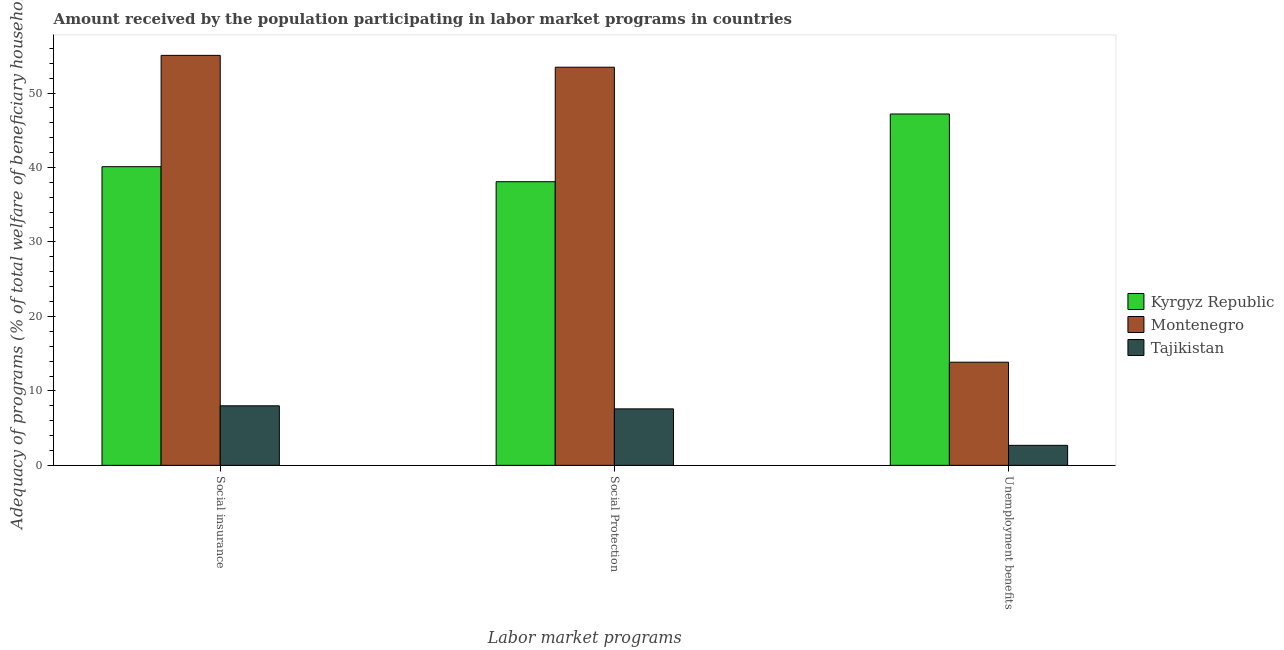Are the number of bars on each tick of the X-axis equal?
Ensure brevity in your answer.  Yes. How many bars are there on the 2nd tick from the right?
Offer a terse response. 3. What is the label of the 2nd group of bars from the left?
Offer a very short reply. Social Protection. What is the amount received by the population participating in unemployment benefits programs in Montenegro?
Your answer should be compact. 13.85. Across all countries, what is the maximum amount received by the population participating in social protection programs?
Your answer should be compact. 53.48. Across all countries, what is the minimum amount received by the population participating in social insurance programs?
Your response must be concise. 8. In which country was the amount received by the population participating in social insurance programs maximum?
Provide a short and direct response. Montenegro. In which country was the amount received by the population participating in unemployment benefits programs minimum?
Give a very brief answer. Tajikistan. What is the total amount received by the population participating in unemployment benefits programs in the graph?
Your answer should be compact. 63.73. What is the difference between the amount received by the population participating in unemployment benefits programs in Tajikistan and that in Montenegro?
Your answer should be very brief. -11.17. What is the difference between the amount received by the population participating in unemployment benefits programs in Montenegro and the amount received by the population participating in social insurance programs in Kyrgyz Republic?
Keep it short and to the point. -26.26. What is the average amount received by the population participating in social insurance programs per country?
Provide a succinct answer. 34.39. What is the difference between the amount received by the population participating in social insurance programs and amount received by the population participating in unemployment benefits programs in Tajikistan?
Ensure brevity in your answer.  5.31. In how many countries, is the amount received by the population participating in social insurance programs greater than 28 %?
Give a very brief answer. 2. What is the ratio of the amount received by the population participating in unemployment benefits programs in Montenegro to that in Kyrgyz Republic?
Offer a very short reply. 0.29. Is the difference between the amount received by the population participating in social insurance programs in Tajikistan and Montenegro greater than the difference between the amount received by the population participating in unemployment benefits programs in Tajikistan and Montenegro?
Offer a terse response. No. What is the difference between the highest and the second highest amount received by the population participating in unemployment benefits programs?
Give a very brief answer. 33.34. What is the difference between the highest and the lowest amount received by the population participating in social insurance programs?
Make the answer very short. 47.07. Is the sum of the amount received by the population participating in social protection programs in Kyrgyz Republic and Montenegro greater than the maximum amount received by the population participating in social insurance programs across all countries?
Provide a succinct answer. Yes. What does the 1st bar from the left in Unemployment benefits represents?
Provide a succinct answer. Kyrgyz Republic. What does the 1st bar from the right in Social insurance represents?
Ensure brevity in your answer.  Tajikistan. What is the difference between two consecutive major ticks on the Y-axis?
Offer a terse response. 10. Does the graph contain any zero values?
Ensure brevity in your answer.  No. Does the graph contain grids?
Your answer should be very brief. No. How many legend labels are there?
Your answer should be compact. 3. What is the title of the graph?
Your answer should be compact. Amount received by the population participating in labor market programs in countries. What is the label or title of the X-axis?
Provide a short and direct response. Labor market programs. What is the label or title of the Y-axis?
Your answer should be compact. Adequacy of programs (% of total welfare of beneficiary households). What is the Adequacy of programs (% of total welfare of beneficiary households) in Kyrgyz Republic in Social insurance?
Offer a very short reply. 40.12. What is the Adequacy of programs (% of total welfare of beneficiary households) of Montenegro in Social insurance?
Give a very brief answer. 55.07. What is the Adequacy of programs (% of total welfare of beneficiary households) in Tajikistan in Social insurance?
Keep it short and to the point. 8. What is the Adequacy of programs (% of total welfare of beneficiary households) of Kyrgyz Republic in Social Protection?
Offer a terse response. 38.1. What is the Adequacy of programs (% of total welfare of beneficiary households) in Montenegro in Social Protection?
Make the answer very short. 53.48. What is the Adequacy of programs (% of total welfare of beneficiary households) of Tajikistan in Social Protection?
Keep it short and to the point. 7.59. What is the Adequacy of programs (% of total welfare of beneficiary households) in Kyrgyz Republic in Unemployment benefits?
Your answer should be very brief. 47.19. What is the Adequacy of programs (% of total welfare of beneficiary households) of Montenegro in Unemployment benefits?
Provide a short and direct response. 13.85. What is the Adequacy of programs (% of total welfare of beneficiary households) in Tajikistan in Unemployment benefits?
Your answer should be compact. 2.69. Across all Labor market programs, what is the maximum Adequacy of programs (% of total welfare of beneficiary households) of Kyrgyz Republic?
Provide a succinct answer. 47.19. Across all Labor market programs, what is the maximum Adequacy of programs (% of total welfare of beneficiary households) of Montenegro?
Provide a short and direct response. 55.07. Across all Labor market programs, what is the maximum Adequacy of programs (% of total welfare of beneficiary households) in Tajikistan?
Keep it short and to the point. 8. Across all Labor market programs, what is the minimum Adequacy of programs (% of total welfare of beneficiary households) in Kyrgyz Republic?
Give a very brief answer. 38.1. Across all Labor market programs, what is the minimum Adequacy of programs (% of total welfare of beneficiary households) in Montenegro?
Offer a very short reply. 13.85. Across all Labor market programs, what is the minimum Adequacy of programs (% of total welfare of beneficiary households) in Tajikistan?
Make the answer very short. 2.69. What is the total Adequacy of programs (% of total welfare of beneficiary households) of Kyrgyz Republic in the graph?
Give a very brief answer. 125.41. What is the total Adequacy of programs (% of total welfare of beneficiary households) in Montenegro in the graph?
Your answer should be compact. 122.4. What is the total Adequacy of programs (% of total welfare of beneficiary households) of Tajikistan in the graph?
Provide a succinct answer. 18.27. What is the difference between the Adequacy of programs (% of total welfare of beneficiary households) in Kyrgyz Republic in Social insurance and that in Social Protection?
Make the answer very short. 2.02. What is the difference between the Adequacy of programs (% of total welfare of beneficiary households) in Montenegro in Social insurance and that in Social Protection?
Ensure brevity in your answer.  1.59. What is the difference between the Adequacy of programs (% of total welfare of beneficiary households) of Tajikistan in Social insurance and that in Social Protection?
Make the answer very short. 0.41. What is the difference between the Adequacy of programs (% of total welfare of beneficiary households) in Kyrgyz Republic in Social insurance and that in Unemployment benefits?
Your answer should be compact. -7.08. What is the difference between the Adequacy of programs (% of total welfare of beneficiary households) of Montenegro in Social insurance and that in Unemployment benefits?
Provide a succinct answer. 41.21. What is the difference between the Adequacy of programs (% of total welfare of beneficiary households) of Tajikistan in Social insurance and that in Unemployment benefits?
Give a very brief answer. 5.31. What is the difference between the Adequacy of programs (% of total welfare of beneficiary households) in Kyrgyz Republic in Social Protection and that in Unemployment benefits?
Ensure brevity in your answer.  -9.09. What is the difference between the Adequacy of programs (% of total welfare of beneficiary households) of Montenegro in Social Protection and that in Unemployment benefits?
Your answer should be very brief. 39.62. What is the difference between the Adequacy of programs (% of total welfare of beneficiary households) of Tajikistan in Social Protection and that in Unemployment benefits?
Keep it short and to the point. 4.9. What is the difference between the Adequacy of programs (% of total welfare of beneficiary households) in Kyrgyz Republic in Social insurance and the Adequacy of programs (% of total welfare of beneficiary households) in Montenegro in Social Protection?
Offer a terse response. -13.36. What is the difference between the Adequacy of programs (% of total welfare of beneficiary households) in Kyrgyz Republic in Social insurance and the Adequacy of programs (% of total welfare of beneficiary households) in Tajikistan in Social Protection?
Offer a very short reply. 32.53. What is the difference between the Adequacy of programs (% of total welfare of beneficiary households) in Montenegro in Social insurance and the Adequacy of programs (% of total welfare of beneficiary households) in Tajikistan in Social Protection?
Your answer should be compact. 47.48. What is the difference between the Adequacy of programs (% of total welfare of beneficiary households) of Kyrgyz Republic in Social insurance and the Adequacy of programs (% of total welfare of beneficiary households) of Montenegro in Unemployment benefits?
Make the answer very short. 26.26. What is the difference between the Adequacy of programs (% of total welfare of beneficiary households) in Kyrgyz Republic in Social insurance and the Adequacy of programs (% of total welfare of beneficiary households) in Tajikistan in Unemployment benefits?
Your answer should be very brief. 37.43. What is the difference between the Adequacy of programs (% of total welfare of beneficiary households) in Montenegro in Social insurance and the Adequacy of programs (% of total welfare of beneficiary households) in Tajikistan in Unemployment benefits?
Provide a short and direct response. 52.38. What is the difference between the Adequacy of programs (% of total welfare of beneficiary households) of Kyrgyz Republic in Social Protection and the Adequacy of programs (% of total welfare of beneficiary households) of Montenegro in Unemployment benefits?
Give a very brief answer. 24.24. What is the difference between the Adequacy of programs (% of total welfare of beneficiary households) in Kyrgyz Republic in Social Protection and the Adequacy of programs (% of total welfare of beneficiary households) in Tajikistan in Unemployment benefits?
Make the answer very short. 35.41. What is the difference between the Adequacy of programs (% of total welfare of beneficiary households) in Montenegro in Social Protection and the Adequacy of programs (% of total welfare of beneficiary households) in Tajikistan in Unemployment benefits?
Make the answer very short. 50.79. What is the average Adequacy of programs (% of total welfare of beneficiary households) of Kyrgyz Republic per Labor market programs?
Provide a short and direct response. 41.8. What is the average Adequacy of programs (% of total welfare of beneficiary households) of Montenegro per Labor market programs?
Your answer should be compact. 40.8. What is the average Adequacy of programs (% of total welfare of beneficiary households) of Tajikistan per Labor market programs?
Ensure brevity in your answer.  6.09. What is the difference between the Adequacy of programs (% of total welfare of beneficiary households) of Kyrgyz Republic and Adequacy of programs (% of total welfare of beneficiary households) of Montenegro in Social insurance?
Ensure brevity in your answer.  -14.95. What is the difference between the Adequacy of programs (% of total welfare of beneficiary households) in Kyrgyz Republic and Adequacy of programs (% of total welfare of beneficiary households) in Tajikistan in Social insurance?
Offer a terse response. 32.12. What is the difference between the Adequacy of programs (% of total welfare of beneficiary households) of Montenegro and Adequacy of programs (% of total welfare of beneficiary households) of Tajikistan in Social insurance?
Provide a short and direct response. 47.07. What is the difference between the Adequacy of programs (% of total welfare of beneficiary households) in Kyrgyz Republic and Adequacy of programs (% of total welfare of beneficiary households) in Montenegro in Social Protection?
Your answer should be compact. -15.38. What is the difference between the Adequacy of programs (% of total welfare of beneficiary households) of Kyrgyz Republic and Adequacy of programs (% of total welfare of beneficiary households) of Tajikistan in Social Protection?
Provide a succinct answer. 30.51. What is the difference between the Adequacy of programs (% of total welfare of beneficiary households) of Montenegro and Adequacy of programs (% of total welfare of beneficiary households) of Tajikistan in Social Protection?
Give a very brief answer. 45.89. What is the difference between the Adequacy of programs (% of total welfare of beneficiary households) in Kyrgyz Republic and Adequacy of programs (% of total welfare of beneficiary households) in Montenegro in Unemployment benefits?
Keep it short and to the point. 33.34. What is the difference between the Adequacy of programs (% of total welfare of beneficiary households) in Kyrgyz Republic and Adequacy of programs (% of total welfare of beneficiary households) in Tajikistan in Unemployment benefits?
Offer a very short reply. 44.5. What is the difference between the Adequacy of programs (% of total welfare of beneficiary households) in Montenegro and Adequacy of programs (% of total welfare of beneficiary households) in Tajikistan in Unemployment benefits?
Offer a very short reply. 11.17. What is the ratio of the Adequacy of programs (% of total welfare of beneficiary households) of Kyrgyz Republic in Social insurance to that in Social Protection?
Ensure brevity in your answer.  1.05. What is the ratio of the Adequacy of programs (% of total welfare of beneficiary households) of Montenegro in Social insurance to that in Social Protection?
Your response must be concise. 1.03. What is the ratio of the Adequacy of programs (% of total welfare of beneficiary households) in Tajikistan in Social insurance to that in Social Protection?
Make the answer very short. 1.05. What is the ratio of the Adequacy of programs (% of total welfare of beneficiary households) of Montenegro in Social insurance to that in Unemployment benefits?
Make the answer very short. 3.97. What is the ratio of the Adequacy of programs (% of total welfare of beneficiary households) of Tajikistan in Social insurance to that in Unemployment benefits?
Offer a terse response. 2.98. What is the ratio of the Adequacy of programs (% of total welfare of beneficiary households) of Kyrgyz Republic in Social Protection to that in Unemployment benefits?
Ensure brevity in your answer.  0.81. What is the ratio of the Adequacy of programs (% of total welfare of beneficiary households) in Montenegro in Social Protection to that in Unemployment benefits?
Ensure brevity in your answer.  3.86. What is the ratio of the Adequacy of programs (% of total welfare of beneficiary households) in Tajikistan in Social Protection to that in Unemployment benefits?
Ensure brevity in your answer.  2.82. What is the difference between the highest and the second highest Adequacy of programs (% of total welfare of beneficiary households) of Kyrgyz Republic?
Give a very brief answer. 7.08. What is the difference between the highest and the second highest Adequacy of programs (% of total welfare of beneficiary households) of Montenegro?
Make the answer very short. 1.59. What is the difference between the highest and the second highest Adequacy of programs (% of total welfare of beneficiary households) in Tajikistan?
Ensure brevity in your answer.  0.41. What is the difference between the highest and the lowest Adequacy of programs (% of total welfare of beneficiary households) of Kyrgyz Republic?
Your response must be concise. 9.09. What is the difference between the highest and the lowest Adequacy of programs (% of total welfare of beneficiary households) in Montenegro?
Your answer should be compact. 41.21. What is the difference between the highest and the lowest Adequacy of programs (% of total welfare of beneficiary households) of Tajikistan?
Give a very brief answer. 5.31. 